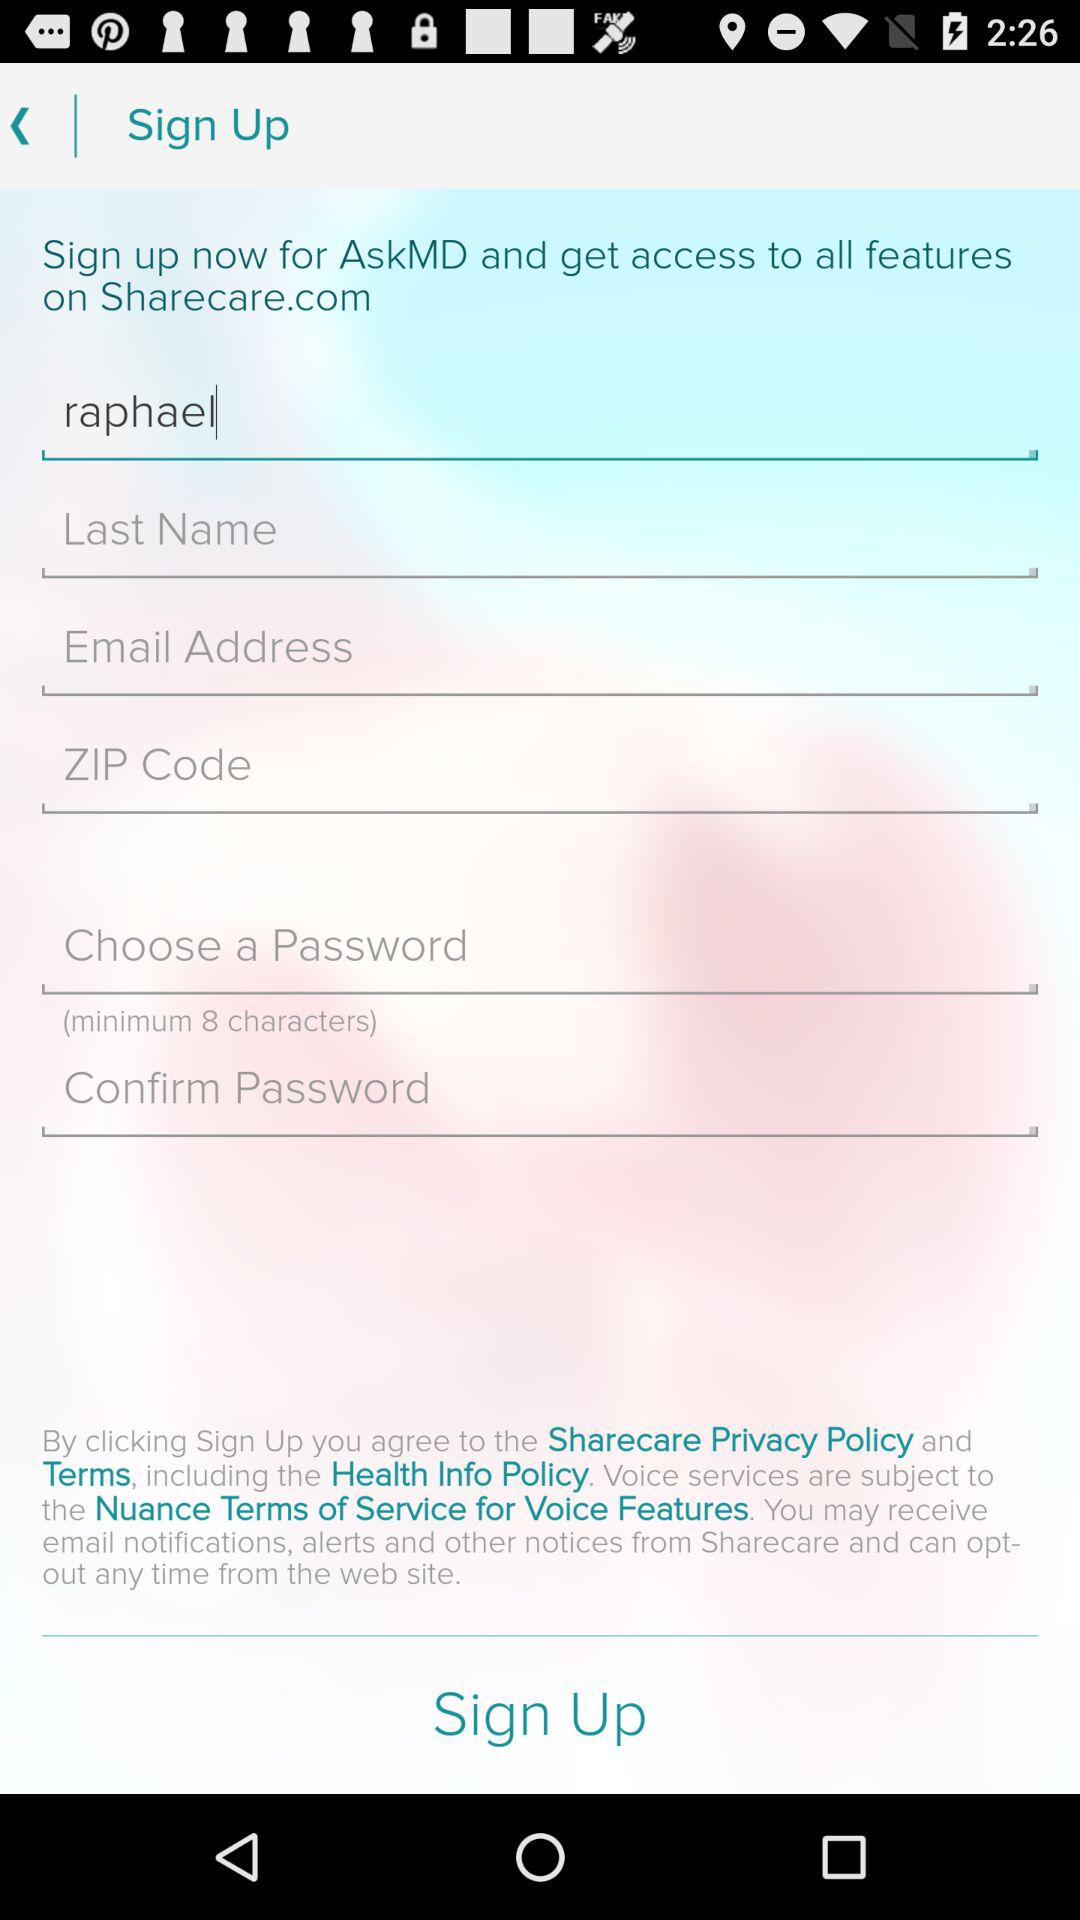How many text inputs are required to sign up for AskMD?
Answer the question using a single word or phrase. 6 